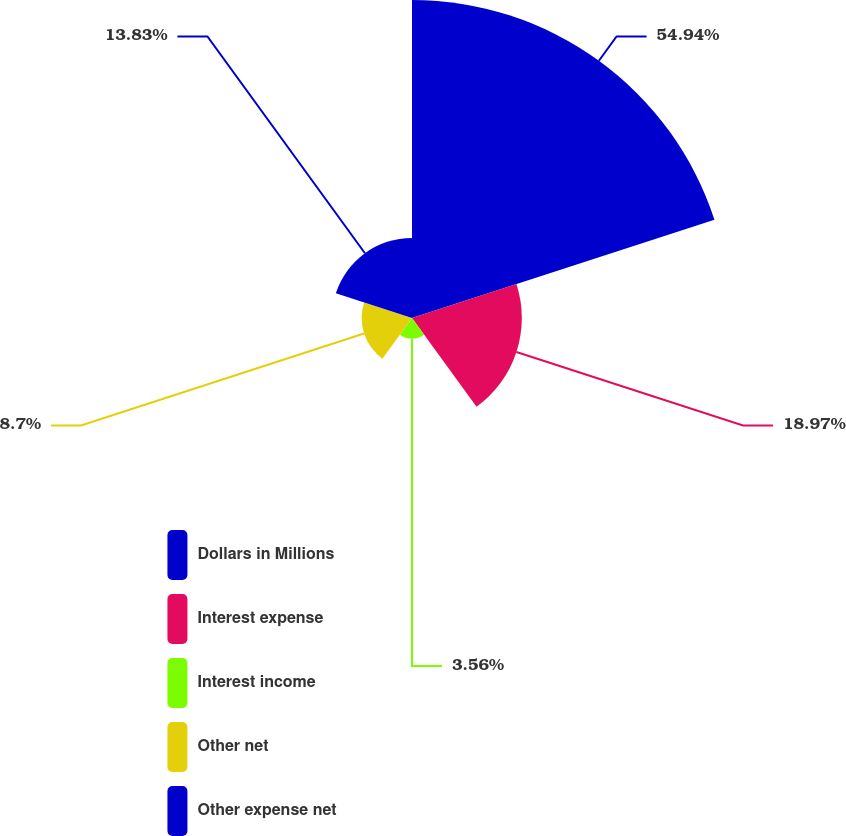Convert chart. <chart><loc_0><loc_0><loc_500><loc_500><pie_chart><fcel>Dollars in Millions<fcel>Interest expense<fcel>Interest income<fcel>Other net<fcel>Other expense net<nl><fcel>54.94%<fcel>18.97%<fcel>3.56%<fcel>8.7%<fcel>13.83%<nl></chart> 